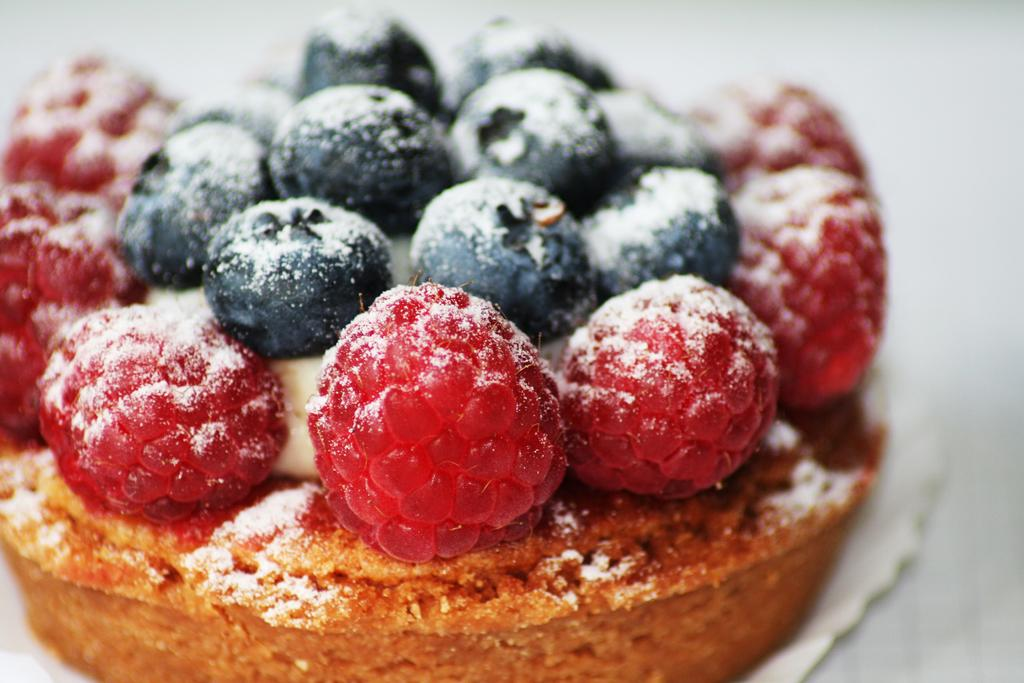What is the main subject of the image? There is a food item in the image. How is the food item presented? The food item is on a paper plate. What time does the clock show in the image? There is no clock present in the image. How many birds are in the flock in the image? There is no flock of birds present in the image. 